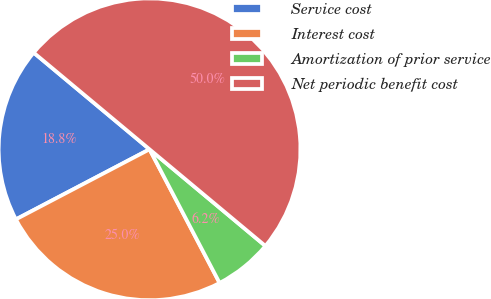<chart> <loc_0><loc_0><loc_500><loc_500><pie_chart><fcel>Service cost<fcel>Interest cost<fcel>Amortization of prior service<fcel>Net periodic benefit cost<nl><fcel>18.75%<fcel>25.0%<fcel>6.25%<fcel>50.0%<nl></chart> 